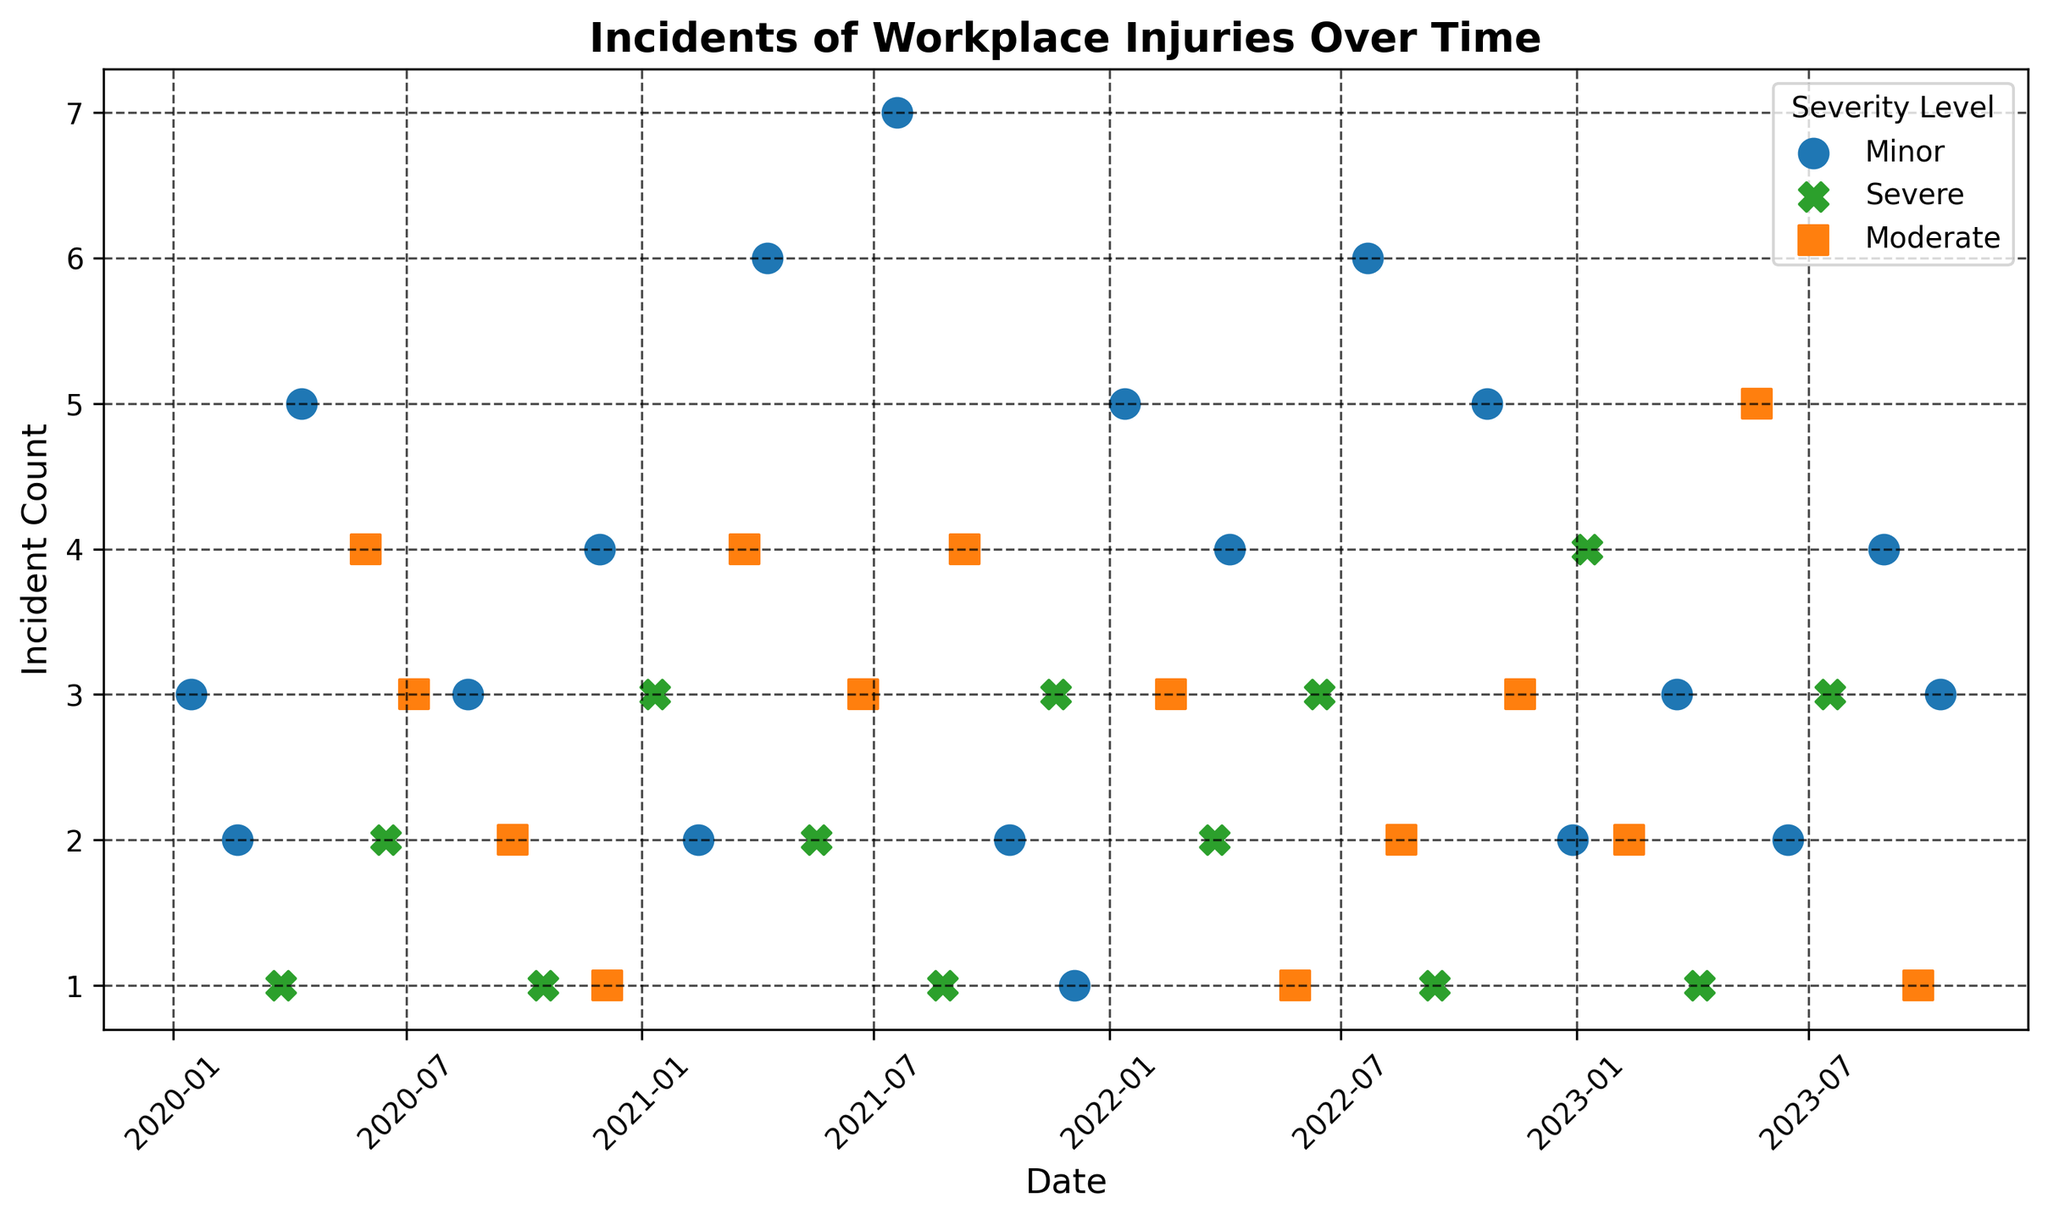Which severity level had the most incidents in March 2021? In March 2021, the incidents are represented by different markers based on severity. Refer to the March 2021 data point and see which severity has the highest incident count.
Answer: Moderate How does the number of severe incidents in 2021 compare to 2022? Count all the severe incidents for 2021 and compare it to the count for 2022. There were severe incidents in January, May, August, and November of 2021, totaling four. In 2022, there were severe incidents in March, June, and September, totaling three.
Answer: 2021 had more severe incidents What is the total number of incidents reported for minor severity in 2022? Sum the incident counts for minor severity in 2022. The incidents were reported in January (5), April (4), July (6), October (5), and December (2). The total is 5+4+6+5+2 = 22.
Answer: 22 How many more incidents were there in July 2021 compared to July 2020? Find the incident counts for July 2021 and July 2020. In July 2020, there were 3 incidents (moderate), and in July 2021, there were 7 incidents (minor). The difference is 7 - 3 = 4.
Answer: 4 Which month from any year had the highest number of severe incidents? Identify the month with the highest incident count marked by 'X' for severe incidents. The highest count is 4 incidents in January 2023.
Answer: January 2023 What is the average number of incidents per month for moderate severity in 2023? Sum the incident counts for moderate severity in 2023 (February, May, and September with counts of 2, 5, and 1, respectively) and divide by the number of months with incidents. The total is 2+5+1 = 8. The average is 8 / 3 = approximately 2.67.
Answer: 2.67 How does the incident frequency trend for minor injuries shift from 2020 to 2023? Plot out the trend for minor injuries year by year: In 2020, there were incidents in January (3), February (2), April (5), August (3), November (4). In 2021: January (2), April (6), July (7), October (2), December (1). In 2022: January (5), April (4), July (6), October (5), December (2). In 2023, there are fewer incidents in each recorded month.
Answer: Increasing initially, then decreasing In which periods were incidents with moderate severity not reported? Identify the months where no moderate incidents are marked. In 2020, March, April, July, and August have no moderate incidents and similar data for 2021 and 2022.
Answer: March-April 2020, July-August 2020, and more specific months Which severity level shows the most variation in incident counts throughout the given time frame? Compare the range of incident counts for each severity level (difference between maximum and minimum counts). Minor ranges from 1 to 7, Moderate ranges from 1 to 5, and Severe ranges from 1 to 4. Minor, therefore, shows the most variation.
Answer: Minor 